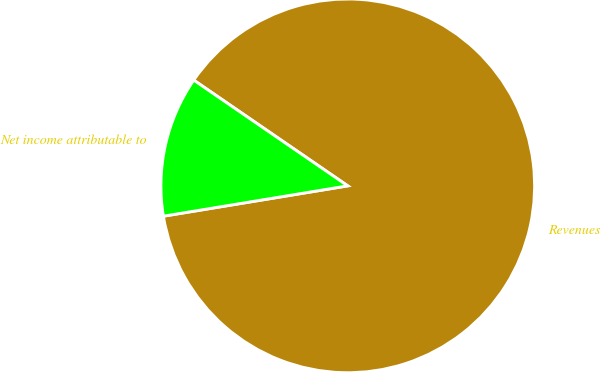Convert chart to OTSL. <chart><loc_0><loc_0><loc_500><loc_500><pie_chart><fcel>Revenues<fcel>Net income attributable to<nl><fcel>87.83%<fcel>12.17%<nl></chart> 